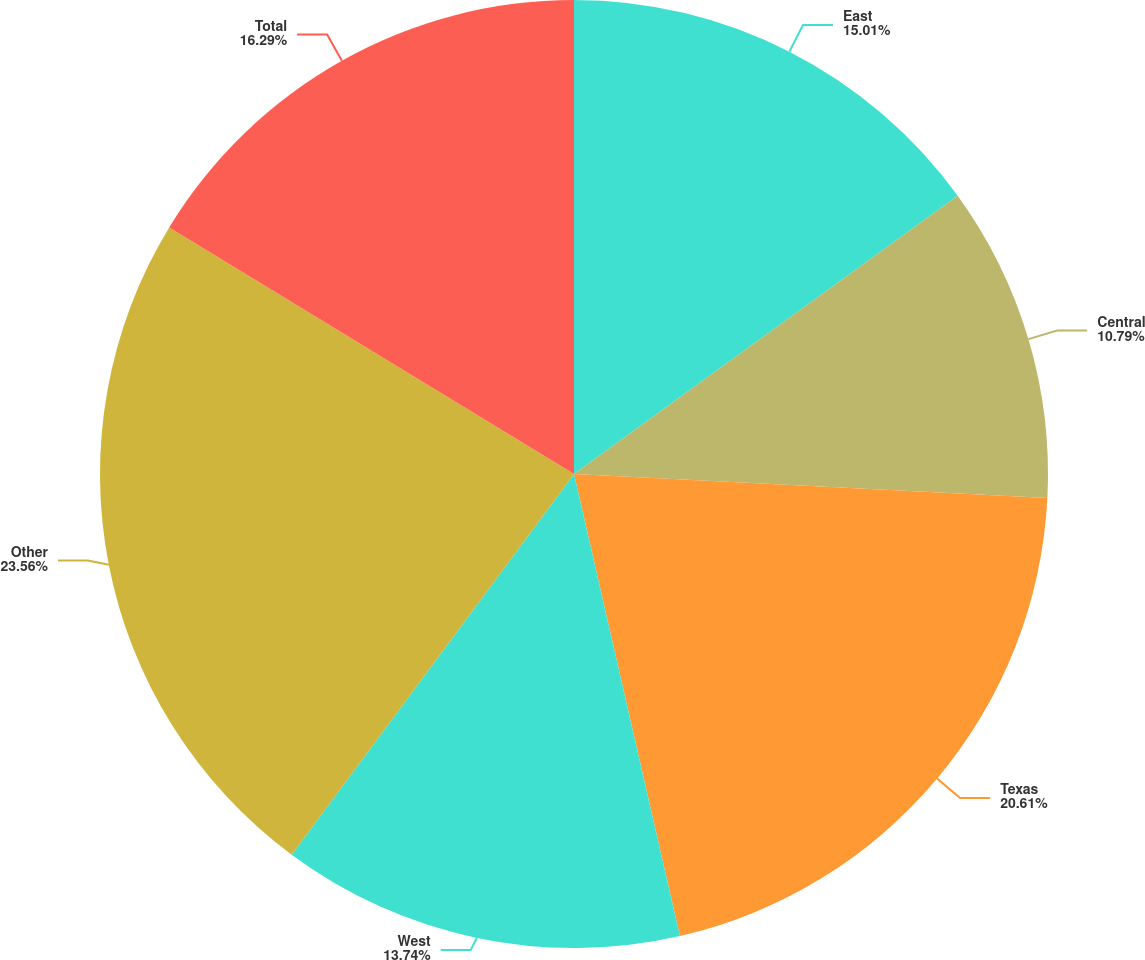Convert chart. <chart><loc_0><loc_0><loc_500><loc_500><pie_chart><fcel>East<fcel>Central<fcel>Texas<fcel>West<fcel>Other<fcel>Total<nl><fcel>15.01%<fcel>10.79%<fcel>20.61%<fcel>13.74%<fcel>23.55%<fcel>16.29%<nl></chart> 